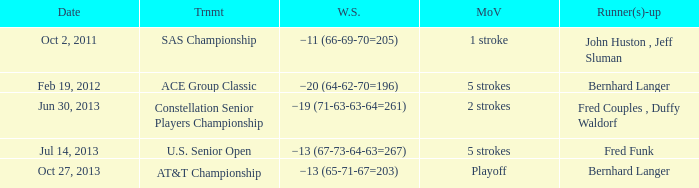On which date did fred funk become a runner-up? Jul 14, 2013. 